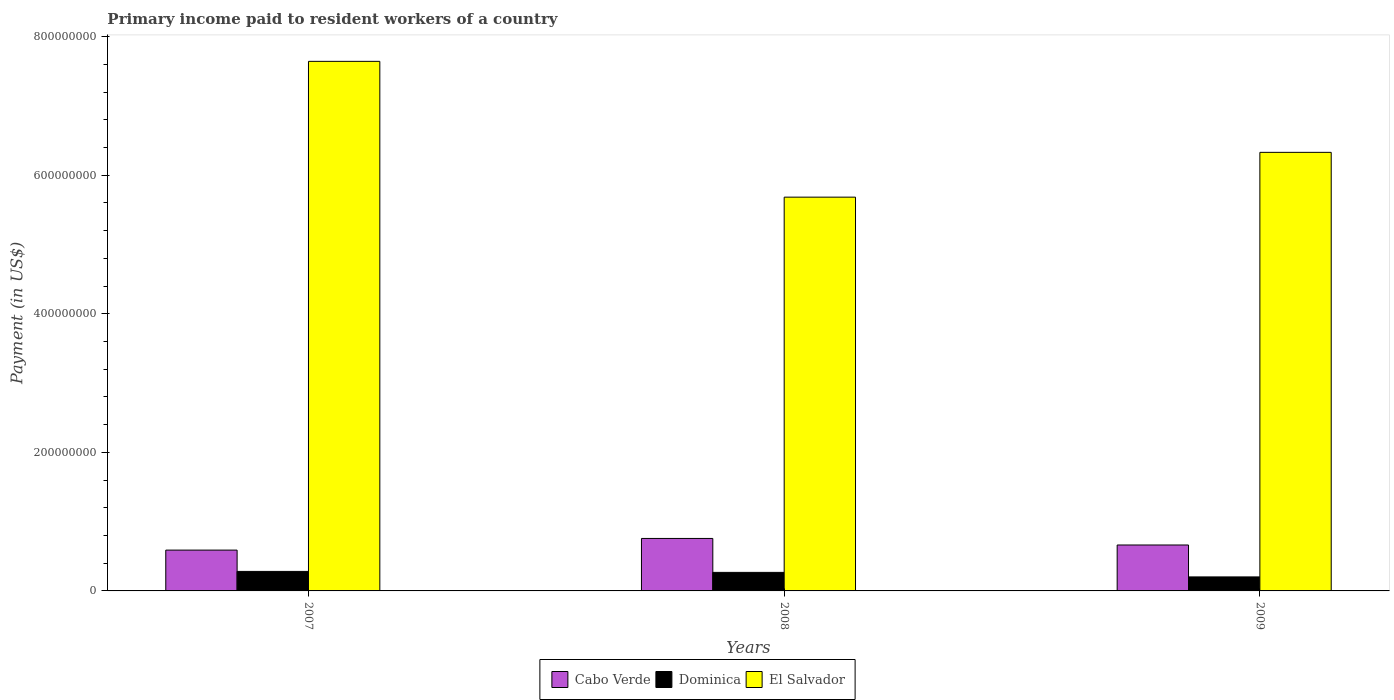How many different coloured bars are there?
Your response must be concise. 3. Are the number of bars per tick equal to the number of legend labels?
Keep it short and to the point. Yes. How many bars are there on the 3rd tick from the right?
Provide a short and direct response. 3. In how many cases, is the number of bars for a given year not equal to the number of legend labels?
Give a very brief answer. 0. What is the amount paid to workers in El Salvador in 2007?
Your response must be concise. 7.64e+08. Across all years, what is the maximum amount paid to workers in El Salvador?
Offer a terse response. 7.64e+08. Across all years, what is the minimum amount paid to workers in Dominica?
Offer a terse response. 2.02e+07. In which year was the amount paid to workers in El Salvador minimum?
Provide a short and direct response. 2008. What is the total amount paid to workers in Dominica in the graph?
Your answer should be very brief. 7.51e+07. What is the difference between the amount paid to workers in Dominica in 2007 and that in 2009?
Offer a very short reply. 7.93e+06. What is the difference between the amount paid to workers in Dominica in 2008 and the amount paid to workers in Cabo Verde in 2009?
Keep it short and to the point. -3.95e+07. What is the average amount paid to workers in El Salvador per year?
Ensure brevity in your answer.  6.55e+08. In the year 2007, what is the difference between the amount paid to workers in El Salvador and amount paid to workers in Dominica?
Offer a very short reply. 7.36e+08. In how many years, is the amount paid to workers in Cabo Verde greater than 600000000 US$?
Make the answer very short. 0. What is the ratio of the amount paid to workers in El Salvador in 2008 to that in 2009?
Keep it short and to the point. 0.9. Is the amount paid to workers in Cabo Verde in 2008 less than that in 2009?
Ensure brevity in your answer.  No. Is the difference between the amount paid to workers in El Salvador in 2007 and 2008 greater than the difference between the amount paid to workers in Dominica in 2007 and 2008?
Provide a succinct answer. Yes. What is the difference between the highest and the second highest amount paid to workers in Cabo Verde?
Keep it short and to the point. 9.44e+06. What is the difference between the highest and the lowest amount paid to workers in El Salvador?
Give a very brief answer. 1.96e+08. In how many years, is the amount paid to workers in Dominica greater than the average amount paid to workers in Dominica taken over all years?
Ensure brevity in your answer.  2. What does the 3rd bar from the left in 2007 represents?
Ensure brevity in your answer.  El Salvador. What does the 1st bar from the right in 2009 represents?
Provide a short and direct response. El Salvador. Is it the case that in every year, the sum of the amount paid to workers in Cabo Verde and amount paid to workers in Dominica is greater than the amount paid to workers in El Salvador?
Ensure brevity in your answer.  No. How many bars are there?
Offer a very short reply. 9. Are all the bars in the graph horizontal?
Keep it short and to the point. No. How many years are there in the graph?
Make the answer very short. 3. What is the difference between two consecutive major ticks on the Y-axis?
Your answer should be very brief. 2.00e+08. Does the graph contain grids?
Give a very brief answer. No. How are the legend labels stacked?
Make the answer very short. Horizontal. What is the title of the graph?
Your answer should be compact. Primary income paid to resident workers of a country. Does "Armenia" appear as one of the legend labels in the graph?
Your answer should be compact. No. What is the label or title of the Y-axis?
Your answer should be compact. Payment (in US$). What is the Payment (in US$) in Cabo Verde in 2007?
Your answer should be compact. 5.89e+07. What is the Payment (in US$) of Dominica in 2007?
Keep it short and to the point. 2.82e+07. What is the Payment (in US$) in El Salvador in 2007?
Ensure brevity in your answer.  7.64e+08. What is the Payment (in US$) of Cabo Verde in 2008?
Provide a short and direct response. 7.57e+07. What is the Payment (in US$) of Dominica in 2008?
Offer a very short reply. 2.68e+07. What is the Payment (in US$) in El Salvador in 2008?
Offer a terse response. 5.68e+08. What is the Payment (in US$) in Cabo Verde in 2009?
Provide a succinct answer. 6.63e+07. What is the Payment (in US$) in Dominica in 2009?
Keep it short and to the point. 2.02e+07. What is the Payment (in US$) of El Salvador in 2009?
Keep it short and to the point. 6.33e+08. Across all years, what is the maximum Payment (in US$) in Cabo Verde?
Make the answer very short. 7.57e+07. Across all years, what is the maximum Payment (in US$) of Dominica?
Ensure brevity in your answer.  2.82e+07. Across all years, what is the maximum Payment (in US$) in El Salvador?
Your answer should be compact. 7.64e+08. Across all years, what is the minimum Payment (in US$) of Cabo Verde?
Offer a very short reply. 5.89e+07. Across all years, what is the minimum Payment (in US$) in Dominica?
Keep it short and to the point. 2.02e+07. Across all years, what is the minimum Payment (in US$) in El Salvador?
Ensure brevity in your answer.  5.68e+08. What is the total Payment (in US$) of Cabo Verde in the graph?
Your answer should be very brief. 2.01e+08. What is the total Payment (in US$) in Dominica in the graph?
Offer a very short reply. 7.51e+07. What is the total Payment (in US$) in El Salvador in the graph?
Keep it short and to the point. 1.97e+09. What is the difference between the Payment (in US$) in Cabo Verde in 2007 and that in 2008?
Make the answer very short. -1.68e+07. What is the difference between the Payment (in US$) of Dominica in 2007 and that in 2008?
Provide a succinct answer. 1.40e+06. What is the difference between the Payment (in US$) of El Salvador in 2007 and that in 2008?
Make the answer very short. 1.96e+08. What is the difference between the Payment (in US$) in Cabo Verde in 2007 and that in 2009?
Provide a succinct answer. -7.39e+06. What is the difference between the Payment (in US$) in Dominica in 2007 and that in 2009?
Keep it short and to the point. 7.93e+06. What is the difference between the Payment (in US$) of El Salvador in 2007 and that in 2009?
Provide a short and direct response. 1.31e+08. What is the difference between the Payment (in US$) in Cabo Verde in 2008 and that in 2009?
Make the answer very short. 9.44e+06. What is the difference between the Payment (in US$) of Dominica in 2008 and that in 2009?
Keep it short and to the point. 6.53e+06. What is the difference between the Payment (in US$) in El Salvador in 2008 and that in 2009?
Offer a very short reply. -6.46e+07. What is the difference between the Payment (in US$) of Cabo Verde in 2007 and the Payment (in US$) of Dominica in 2008?
Give a very brief answer. 3.21e+07. What is the difference between the Payment (in US$) in Cabo Verde in 2007 and the Payment (in US$) in El Salvador in 2008?
Provide a short and direct response. -5.09e+08. What is the difference between the Payment (in US$) of Dominica in 2007 and the Payment (in US$) of El Salvador in 2008?
Provide a succinct answer. -5.40e+08. What is the difference between the Payment (in US$) in Cabo Verde in 2007 and the Payment (in US$) in Dominica in 2009?
Provide a short and direct response. 3.87e+07. What is the difference between the Payment (in US$) in Cabo Verde in 2007 and the Payment (in US$) in El Salvador in 2009?
Keep it short and to the point. -5.74e+08. What is the difference between the Payment (in US$) of Dominica in 2007 and the Payment (in US$) of El Salvador in 2009?
Your response must be concise. -6.05e+08. What is the difference between the Payment (in US$) of Cabo Verde in 2008 and the Payment (in US$) of Dominica in 2009?
Offer a very short reply. 5.55e+07. What is the difference between the Payment (in US$) in Cabo Verde in 2008 and the Payment (in US$) in El Salvador in 2009?
Your response must be concise. -5.57e+08. What is the difference between the Payment (in US$) of Dominica in 2008 and the Payment (in US$) of El Salvador in 2009?
Provide a short and direct response. -6.06e+08. What is the average Payment (in US$) of Cabo Verde per year?
Your answer should be compact. 6.70e+07. What is the average Payment (in US$) of Dominica per year?
Give a very brief answer. 2.50e+07. What is the average Payment (in US$) in El Salvador per year?
Your response must be concise. 6.55e+08. In the year 2007, what is the difference between the Payment (in US$) of Cabo Verde and Payment (in US$) of Dominica?
Offer a terse response. 3.07e+07. In the year 2007, what is the difference between the Payment (in US$) of Cabo Verde and Payment (in US$) of El Salvador?
Give a very brief answer. -7.05e+08. In the year 2007, what is the difference between the Payment (in US$) of Dominica and Payment (in US$) of El Salvador?
Keep it short and to the point. -7.36e+08. In the year 2008, what is the difference between the Payment (in US$) in Cabo Verde and Payment (in US$) in Dominica?
Your response must be concise. 4.90e+07. In the year 2008, what is the difference between the Payment (in US$) of Cabo Verde and Payment (in US$) of El Salvador?
Keep it short and to the point. -4.93e+08. In the year 2008, what is the difference between the Payment (in US$) in Dominica and Payment (in US$) in El Salvador?
Provide a short and direct response. -5.42e+08. In the year 2009, what is the difference between the Payment (in US$) in Cabo Verde and Payment (in US$) in Dominica?
Keep it short and to the point. 4.61e+07. In the year 2009, what is the difference between the Payment (in US$) of Cabo Verde and Payment (in US$) of El Salvador?
Your response must be concise. -5.67e+08. In the year 2009, what is the difference between the Payment (in US$) in Dominica and Payment (in US$) in El Salvador?
Keep it short and to the point. -6.13e+08. What is the ratio of the Payment (in US$) in Cabo Verde in 2007 to that in 2008?
Make the answer very short. 0.78. What is the ratio of the Payment (in US$) of Dominica in 2007 to that in 2008?
Provide a short and direct response. 1.05. What is the ratio of the Payment (in US$) in El Salvador in 2007 to that in 2008?
Your answer should be compact. 1.34. What is the ratio of the Payment (in US$) of Cabo Verde in 2007 to that in 2009?
Your answer should be very brief. 0.89. What is the ratio of the Payment (in US$) in Dominica in 2007 to that in 2009?
Provide a short and direct response. 1.39. What is the ratio of the Payment (in US$) in El Salvador in 2007 to that in 2009?
Your answer should be compact. 1.21. What is the ratio of the Payment (in US$) in Cabo Verde in 2008 to that in 2009?
Provide a short and direct response. 1.14. What is the ratio of the Payment (in US$) in Dominica in 2008 to that in 2009?
Your answer should be compact. 1.32. What is the ratio of the Payment (in US$) of El Salvador in 2008 to that in 2009?
Your answer should be compact. 0.9. What is the difference between the highest and the second highest Payment (in US$) in Cabo Verde?
Provide a succinct answer. 9.44e+06. What is the difference between the highest and the second highest Payment (in US$) in Dominica?
Offer a terse response. 1.40e+06. What is the difference between the highest and the second highest Payment (in US$) in El Salvador?
Keep it short and to the point. 1.31e+08. What is the difference between the highest and the lowest Payment (in US$) in Cabo Verde?
Provide a succinct answer. 1.68e+07. What is the difference between the highest and the lowest Payment (in US$) of Dominica?
Offer a terse response. 7.93e+06. What is the difference between the highest and the lowest Payment (in US$) in El Salvador?
Offer a terse response. 1.96e+08. 